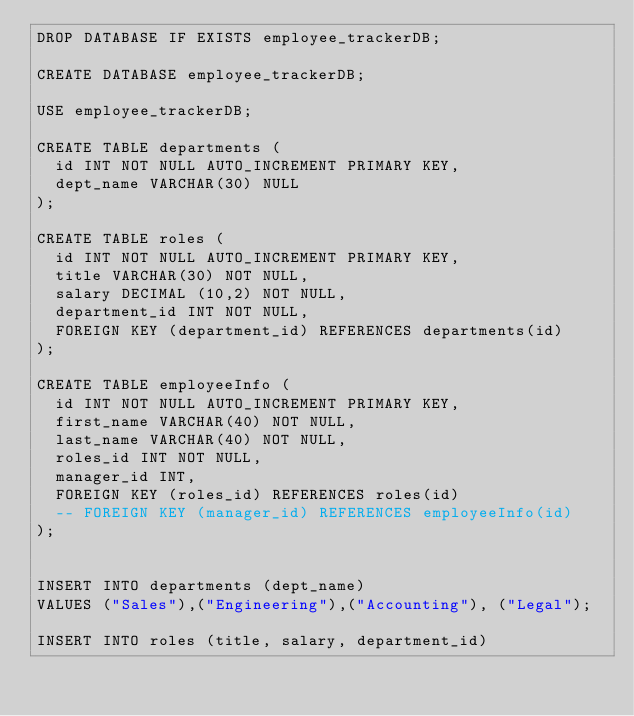Convert code to text. <code><loc_0><loc_0><loc_500><loc_500><_SQL_>DROP DATABASE IF EXISTS employee_trackerDB;

CREATE DATABASE employee_trackerDB;

USE employee_trackerDB;

CREATE TABLE departments (
  id INT NOT NULL AUTO_INCREMENT PRIMARY KEY,
  dept_name VARCHAR(30) NULL
);

CREATE TABLE roles (
  id INT NOT NULL AUTO_INCREMENT PRIMARY KEY,
  title VARCHAR(30) NOT NULL,
  salary DECIMAL (10,2) NOT NULL,
  department_id INT NOT NULL,
  FOREIGN KEY (department_id) REFERENCES departments(id)
);

CREATE TABLE employeeInfo (
  id INT NOT NULL AUTO_INCREMENT PRIMARY KEY,
  first_name VARCHAR(40) NOT NULL,
  last_name VARCHAR(40) NOT NULL, 
  roles_id INT NOT NULL,
  manager_id INT,
  FOREIGN KEY (roles_id) REFERENCES roles(id)
  -- FOREIGN KEY (manager_id) REFERENCES employeeInfo(id)
);


INSERT INTO departments (dept_name)
VALUES ("Sales"),("Engineering"),("Accounting"), ("Legal");

INSERT INTO roles (title, salary, department_id)</code> 